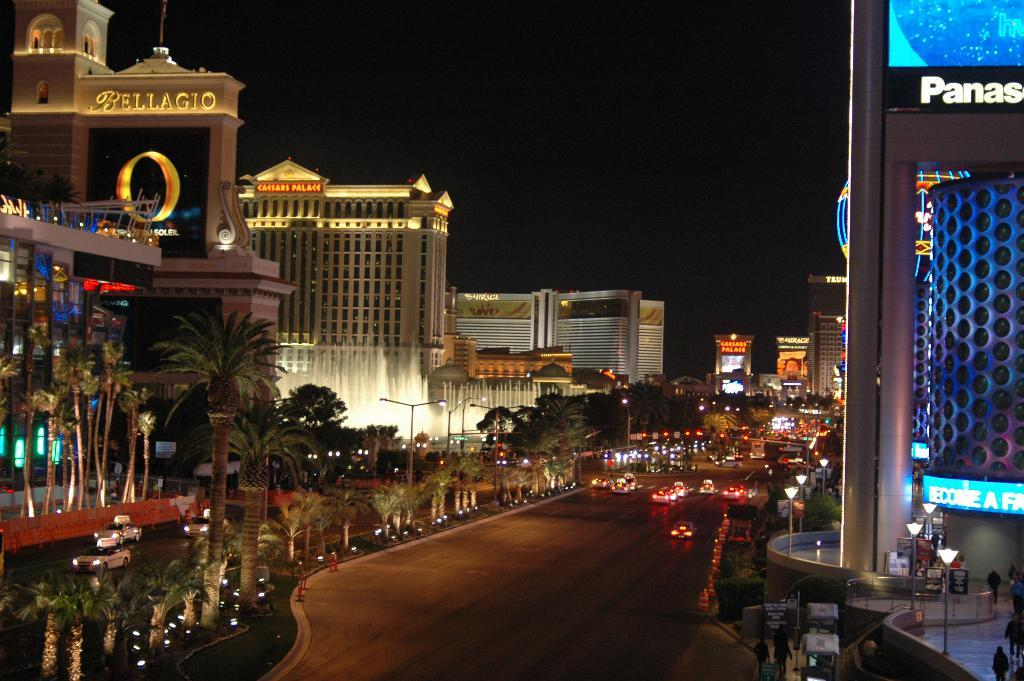Provide a one-sentence caption for the provided image. A panoramic shot of a vibrant street in Las Vegas featuring the Pallgio. 